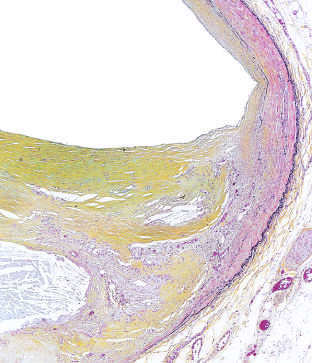s the plaque stained for elastin (black)?
Answer the question using a single word or phrase. Yes 